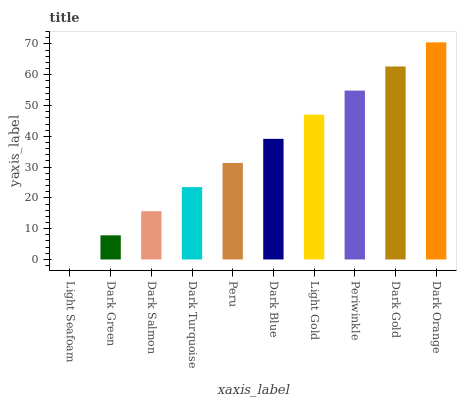Is Dark Green the minimum?
Answer yes or no. No. Is Dark Green the maximum?
Answer yes or no. No. Is Dark Green greater than Light Seafoam?
Answer yes or no. Yes. Is Light Seafoam less than Dark Green?
Answer yes or no. Yes. Is Light Seafoam greater than Dark Green?
Answer yes or no. No. Is Dark Green less than Light Seafoam?
Answer yes or no. No. Is Dark Blue the high median?
Answer yes or no. Yes. Is Peru the low median?
Answer yes or no. Yes. Is Dark Salmon the high median?
Answer yes or no. No. Is Dark Green the low median?
Answer yes or no. No. 